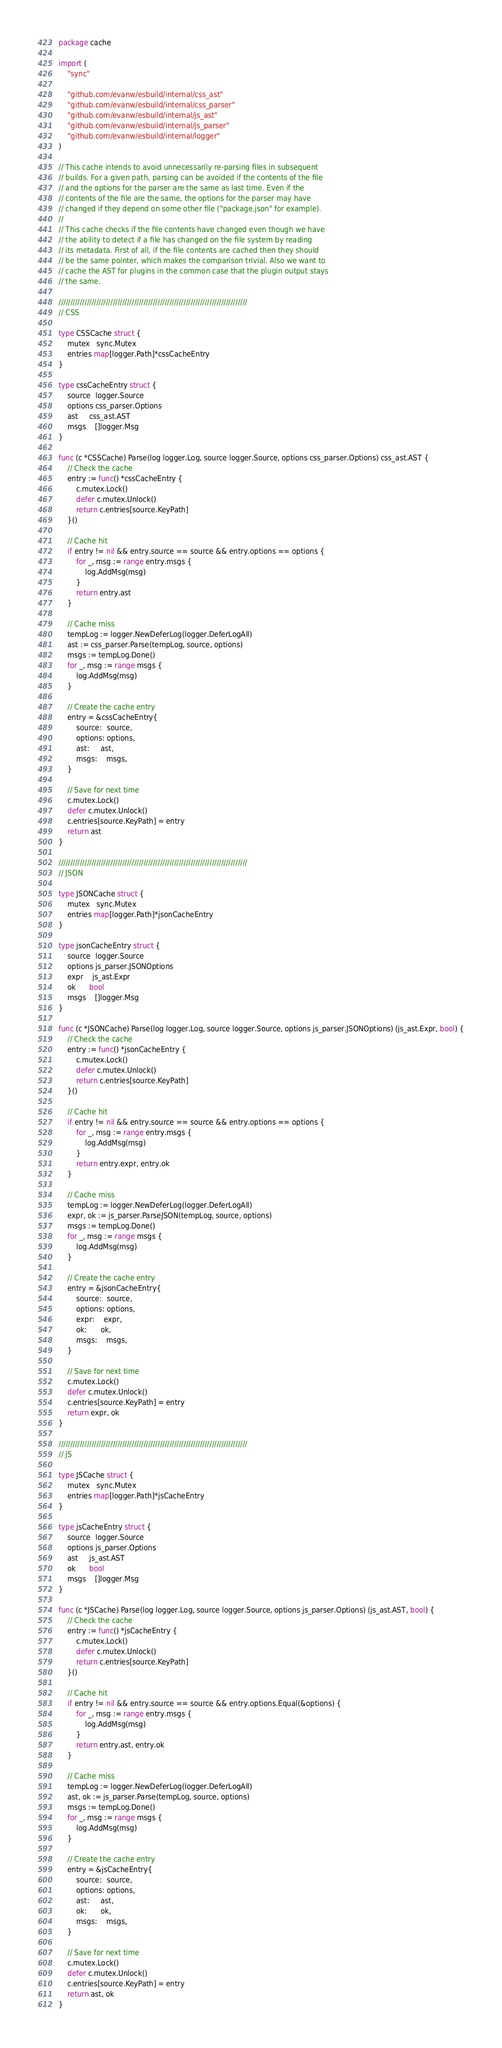<code> <loc_0><loc_0><loc_500><loc_500><_Go_>package cache

import (
	"sync"

	"github.com/evanw/esbuild/internal/css_ast"
	"github.com/evanw/esbuild/internal/css_parser"
	"github.com/evanw/esbuild/internal/js_ast"
	"github.com/evanw/esbuild/internal/js_parser"
	"github.com/evanw/esbuild/internal/logger"
)

// This cache intends to avoid unnecessarily re-parsing files in subsequent
// builds. For a given path, parsing can be avoided if the contents of the file
// and the options for the parser are the same as last time. Even if the
// contents of the file are the same, the options for the parser may have
// changed if they depend on some other file ("package.json" for example).
//
// This cache checks if the file contents have changed even though we have
// the ability to detect if a file has changed on the file system by reading
// its metadata. First of all, if the file contents are cached then they should
// be the same pointer, which makes the comparison trivial. Also we want to
// cache the AST for plugins in the common case that the plugin output stays
// the same.

////////////////////////////////////////////////////////////////////////////////
// CSS

type CSSCache struct {
	mutex   sync.Mutex
	entries map[logger.Path]*cssCacheEntry
}

type cssCacheEntry struct {
	source  logger.Source
	options css_parser.Options
	ast     css_ast.AST
	msgs    []logger.Msg
}

func (c *CSSCache) Parse(log logger.Log, source logger.Source, options css_parser.Options) css_ast.AST {
	// Check the cache
	entry := func() *cssCacheEntry {
		c.mutex.Lock()
		defer c.mutex.Unlock()
		return c.entries[source.KeyPath]
	}()

	// Cache hit
	if entry != nil && entry.source == source && entry.options == options {
		for _, msg := range entry.msgs {
			log.AddMsg(msg)
		}
		return entry.ast
	}

	// Cache miss
	tempLog := logger.NewDeferLog(logger.DeferLogAll)
	ast := css_parser.Parse(tempLog, source, options)
	msgs := tempLog.Done()
	for _, msg := range msgs {
		log.AddMsg(msg)
	}

	// Create the cache entry
	entry = &cssCacheEntry{
		source:  source,
		options: options,
		ast:     ast,
		msgs:    msgs,
	}

	// Save for next time
	c.mutex.Lock()
	defer c.mutex.Unlock()
	c.entries[source.KeyPath] = entry
	return ast
}

////////////////////////////////////////////////////////////////////////////////
// JSON

type JSONCache struct {
	mutex   sync.Mutex
	entries map[logger.Path]*jsonCacheEntry
}

type jsonCacheEntry struct {
	source  logger.Source
	options js_parser.JSONOptions
	expr    js_ast.Expr
	ok      bool
	msgs    []logger.Msg
}

func (c *JSONCache) Parse(log logger.Log, source logger.Source, options js_parser.JSONOptions) (js_ast.Expr, bool) {
	// Check the cache
	entry := func() *jsonCacheEntry {
		c.mutex.Lock()
		defer c.mutex.Unlock()
		return c.entries[source.KeyPath]
	}()

	// Cache hit
	if entry != nil && entry.source == source && entry.options == options {
		for _, msg := range entry.msgs {
			log.AddMsg(msg)
		}
		return entry.expr, entry.ok
	}

	// Cache miss
	tempLog := logger.NewDeferLog(logger.DeferLogAll)
	expr, ok := js_parser.ParseJSON(tempLog, source, options)
	msgs := tempLog.Done()
	for _, msg := range msgs {
		log.AddMsg(msg)
	}

	// Create the cache entry
	entry = &jsonCacheEntry{
		source:  source,
		options: options,
		expr:    expr,
		ok:      ok,
		msgs:    msgs,
	}

	// Save for next time
	c.mutex.Lock()
	defer c.mutex.Unlock()
	c.entries[source.KeyPath] = entry
	return expr, ok
}

////////////////////////////////////////////////////////////////////////////////
// JS

type JSCache struct {
	mutex   sync.Mutex
	entries map[logger.Path]*jsCacheEntry
}

type jsCacheEntry struct {
	source  logger.Source
	options js_parser.Options
	ast     js_ast.AST
	ok      bool
	msgs    []logger.Msg
}

func (c *JSCache) Parse(log logger.Log, source logger.Source, options js_parser.Options) (js_ast.AST, bool) {
	// Check the cache
	entry := func() *jsCacheEntry {
		c.mutex.Lock()
		defer c.mutex.Unlock()
		return c.entries[source.KeyPath]
	}()

	// Cache hit
	if entry != nil && entry.source == source && entry.options.Equal(&options) {
		for _, msg := range entry.msgs {
			log.AddMsg(msg)
		}
		return entry.ast, entry.ok
	}

	// Cache miss
	tempLog := logger.NewDeferLog(logger.DeferLogAll)
	ast, ok := js_parser.Parse(tempLog, source, options)
	msgs := tempLog.Done()
	for _, msg := range msgs {
		log.AddMsg(msg)
	}

	// Create the cache entry
	entry = &jsCacheEntry{
		source:  source,
		options: options,
		ast:     ast,
		ok:      ok,
		msgs:    msgs,
	}

	// Save for next time
	c.mutex.Lock()
	defer c.mutex.Unlock()
	c.entries[source.KeyPath] = entry
	return ast, ok
}
</code> 